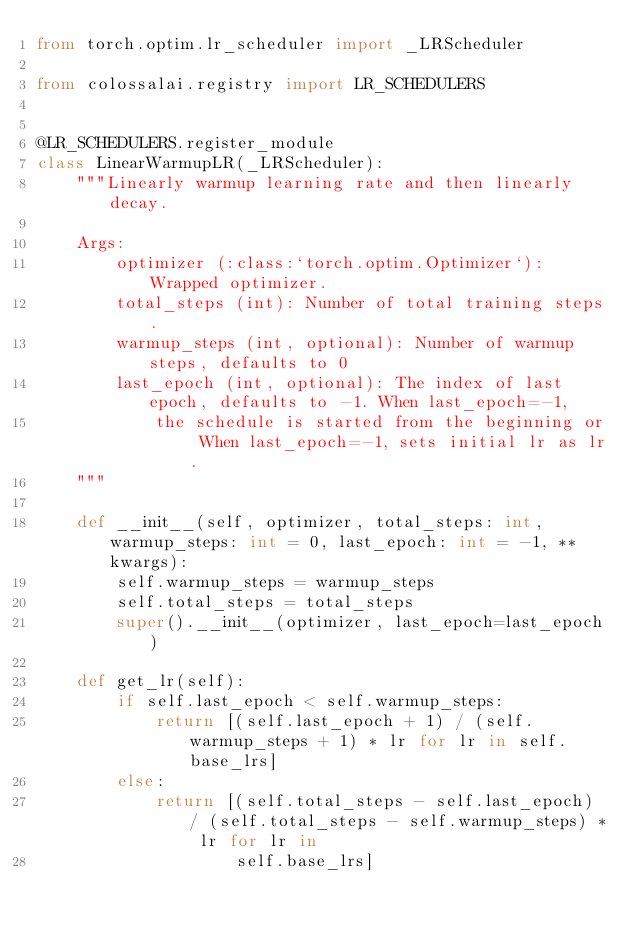Convert code to text. <code><loc_0><loc_0><loc_500><loc_500><_Python_>from torch.optim.lr_scheduler import _LRScheduler

from colossalai.registry import LR_SCHEDULERS


@LR_SCHEDULERS.register_module
class LinearWarmupLR(_LRScheduler):
    """Linearly warmup learning rate and then linearly decay.

    Args:
        optimizer (:class:`torch.optim.Optimizer`): Wrapped optimizer.
        total_steps (int): Number of total training steps.
        warmup_steps (int, optional): Number of warmup steps, defaults to 0
        last_epoch (int, optional): The index of last epoch, defaults to -1. When last_epoch=-1,
            the schedule is started from the beginning or When last_epoch=-1, sets initial lr as lr.
    """

    def __init__(self, optimizer, total_steps: int, warmup_steps: int = 0, last_epoch: int = -1, **kwargs):
        self.warmup_steps = warmup_steps
        self.total_steps = total_steps
        super().__init__(optimizer, last_epoch=last_epoch)

    def get_lr(self):
        if self.last_epoch < self.warmup_steps:
            return [(self.last_epoch + 1) / (self.warmup_steps + 1) * lr for lr in self.base_lrs]
        else:
            return [(self.total_steps - self.last_epoch) / (self.total_steps - self.warmup_steps) * lr for lr in
                    self.base_lrs]
</code> 